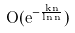Convert formula to latex. <formula><loc_0><loc_0><loc_500><loc_500>O ( e ^ { - \frac { k n } { \ln n } } )</formula> 